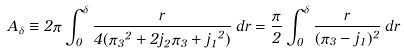Convert formula to latex. <formula><loc_0><loc_0><loc_500><loc_500>A _ { \delta } \equiv 2 \pi \int _ { 0 } ^ { \delta } \frac { r } { 4 ( { \pi _ { 3 } } ^ { 2 } + 2 j _ { 2 } \pi _ { 3 } + { j _ { 1 } } ^ { 2 } ) } \, d r = \frac { \pi } { 2 } \int _ { 0 } ^ { \delta } \frac { r } { ( \pi _ { 3 } - j _ { 1 } ) ^ { 2 } } \, d r</formula> 